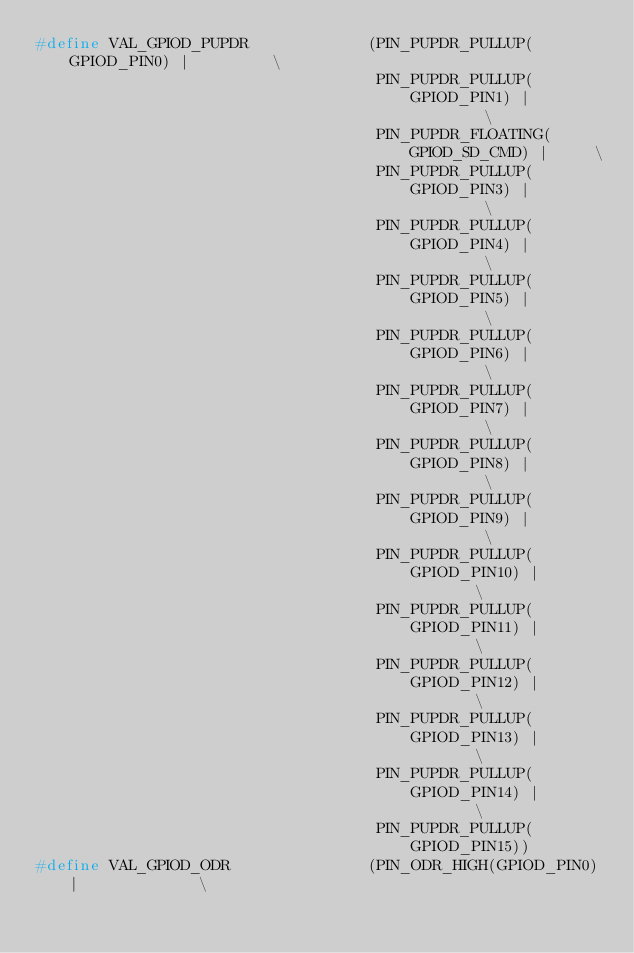<code> <loc_0><loc_0><loc_500><loc_500><_C_>#define VAL_GPIOD_PUPDR             (PIN_PUPDR_PULLUP(GPIOD_PIN0) |         \
                                     PIN_PUPDR_PULLUP(GPIOD_PIN1) |         \
                                     PIN_PUPDR_FLOATING(GPIOD_SD_CMD) |     \
                                     PIN_PUPDR_PULLUP(GPIOD_PIN3) |         \
                                     PIN_PUPDR_PULLUP(GPIOD_PIN4) |         \
                                     PIN_PUPDR_PULLUP(GPIOD_PIN5) |         \
                                     PIN_PUPDR_PULLUP(GPIOD_PIN6) |         \
                                     PIN_PUPDR_PULLUP(GPIOD_PIN7) |         \
                                     PIN_PUPDR_PULLUP(GPIOD_PIN8) |         \
                                     PIN_PUPDR_PULLUP(GPIOD_PIN9) |         \
                                     PIN_PUPDR_PULLUP(GPIOD_PIN10) |        \
                                     PIN_PUPDR_PULLUP(GPIOD_PIN11) |        \
                                     PIN_PUPDR_PULLUP(GPIOD_PIN12) |        \
                                     PIN_PUPDR_PULLUP(GPIOD_PIN13) |        \
                                     PIN_PUPDR_PULLUP(GPIOD_PIN14) |        \
                                     PIN_PUPDR_PULLUP(GPIOD_PIN15))
#define VAL_GPIOD_ODR               (PIN_ODR_HIGH(GPIOD_PIN0) |             \</code> 